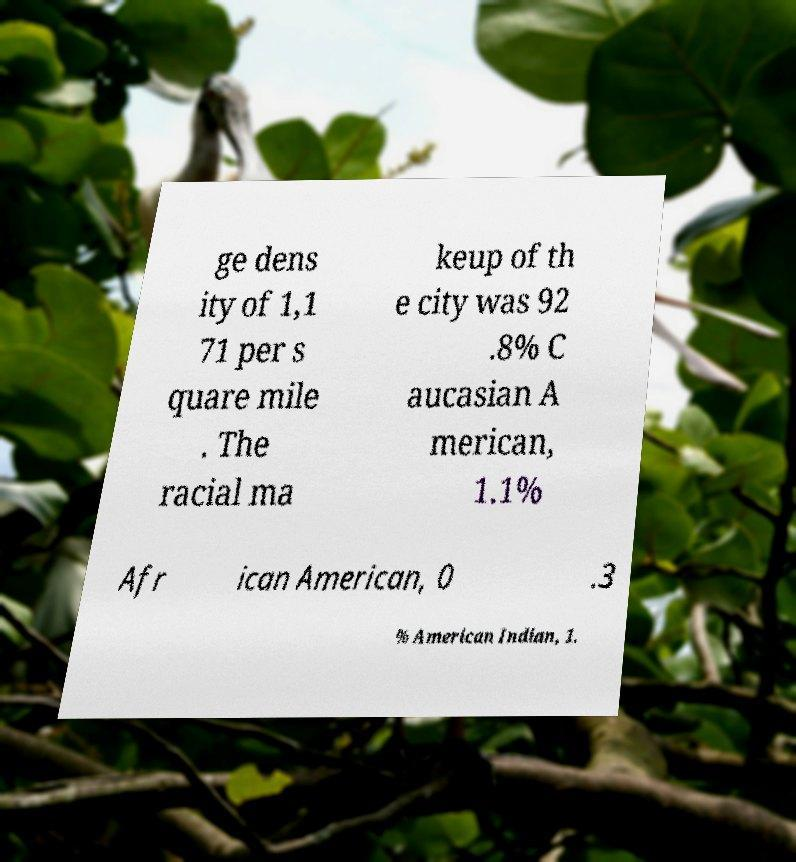There's text embedded in this image that I need extracted. Can you transcribe it verbatim? ge dens ity of 1,1 71 per s quare mile . The racial ma keup of th e city was 92 .8% C aucasian A merican, 1.1% Afr ican American, 0 .3 % American Indian, 1. 